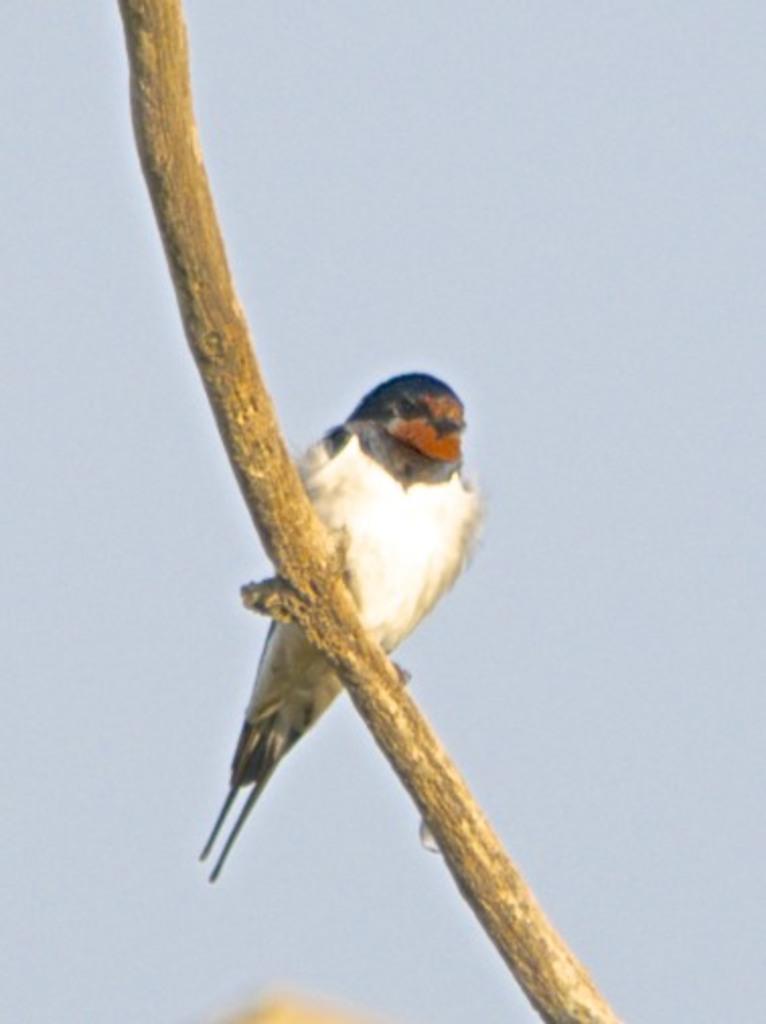Could you give a brief overview of what you see in this image? In this image, we can see a bird on the stick which is on the blue background. 